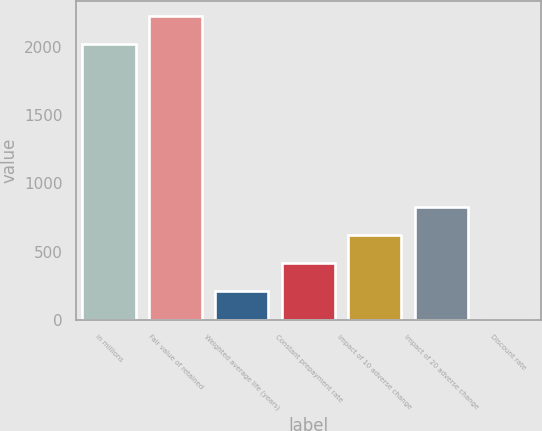<chart> <loc_0><loc_0><loc_500><loc_500><bar_chart><fcel>in millions<fcel>Fair value of retained<fcel>Weighted average life (years)<fcel>Constant prepayment rate<fcel>Impact of 10 adverse change<fcel>Impact of 20 adverse change<fcel>Discount rate<nl><fcel>2017<fcel>2223.68<fcel>210.88<fcel>417.56<fcel>624.24<fcel>830.92<fcel>4.2<nl></chart> 